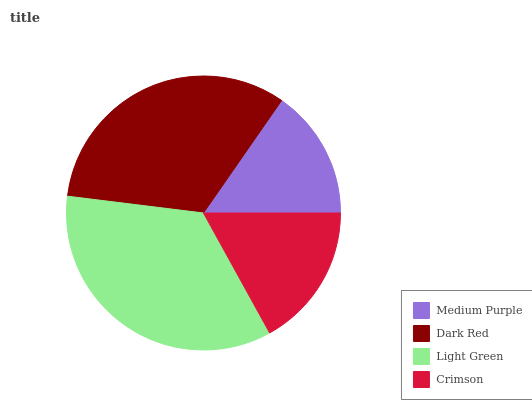Is Medium Purple the minimum?
Answer yes or no. Yes. Is Light Green the maximum?
Answer yes or no. Yes. Is Dark Red the minimum?
Answer yes or no. No. Is Dark Red the maximum?
Answer yes or no. No. Is Dark Red greater than Medium Purple?
Answer yes or no. Yes. Is Medium Purple less than Dark Red?
Answer yes or no. Yes. Is Medium Purple greater than Dark Red?
Answer yes or no. No. Is Dark Red less than Medium Purple?
Answer yes or no. No. Is Dark Red the high median?
Answer yes or no. Yes. Is Crimson the low median?
Answer yes or no. Yes. Is Light Green the high median?
Answer yes or no. No. Is Medium Purple the low median?
Answer yes or no. No. 